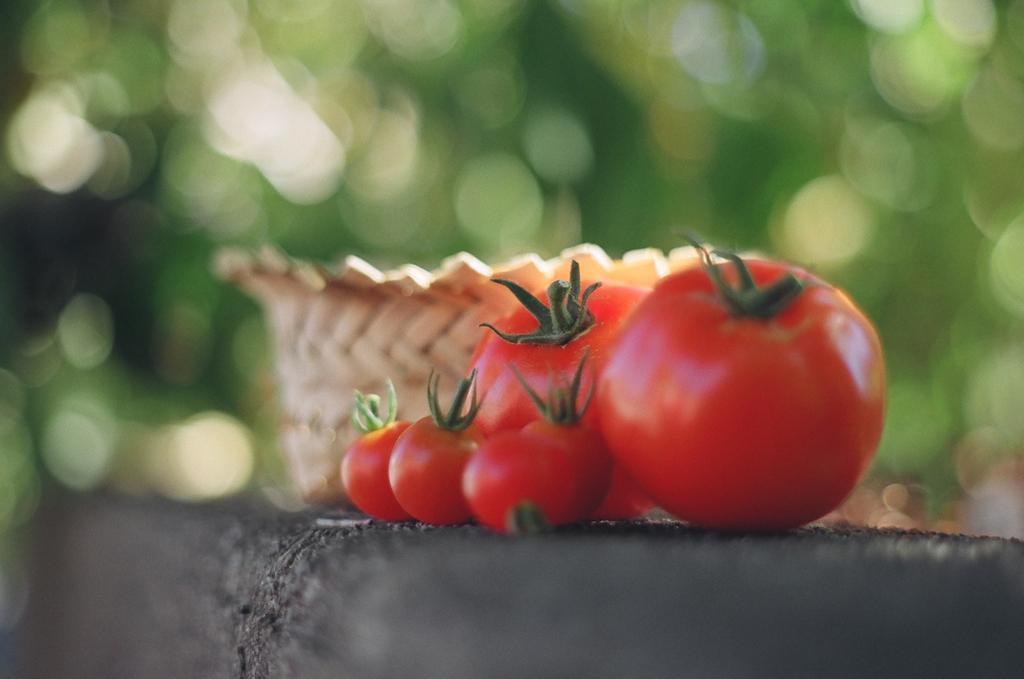How would you summarize this image in a sentence or two? In this image I see 5 tomatoes which are of red and green in color and I see a basket over here which is of light brown in color and these things are on the black surface and it is blurred in the background. 